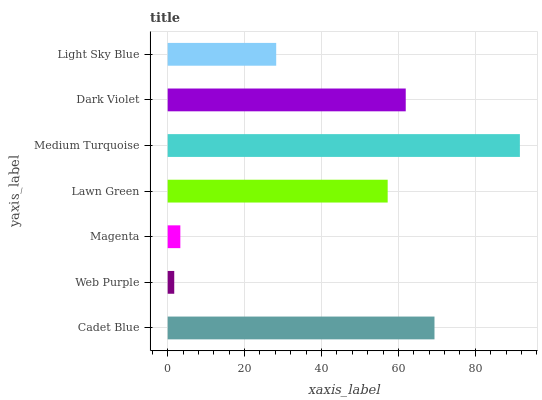Is Web Purple the minimum?
Answer yes or no. Yes. Is Medium Turquoise the maximum?
Answer yes or no. Yes. Is Magenta the minimum?
Answer yes or no. No. Is Magenta the maximum?
Answer yes or no. No. Is Magenta greater than Web Purple?
Answer yes or no. Yes. Is Web Purple less than Magenta?
Answer yes or no. Yes. Is Web Purple greater than Magenta?
Answer yes or no. No. Is Magenta less than Web Purple?
Answer yes or no. No. Is Lawn Green the high median?
Answer yes or no. Yes. Is Lawn Green the low median?
Answer yes or no. Yes. Is Light Sky Blue the high median?
Answer yes or no. No. Is Cadet Blue the low median?
Answer yes or no. No. 